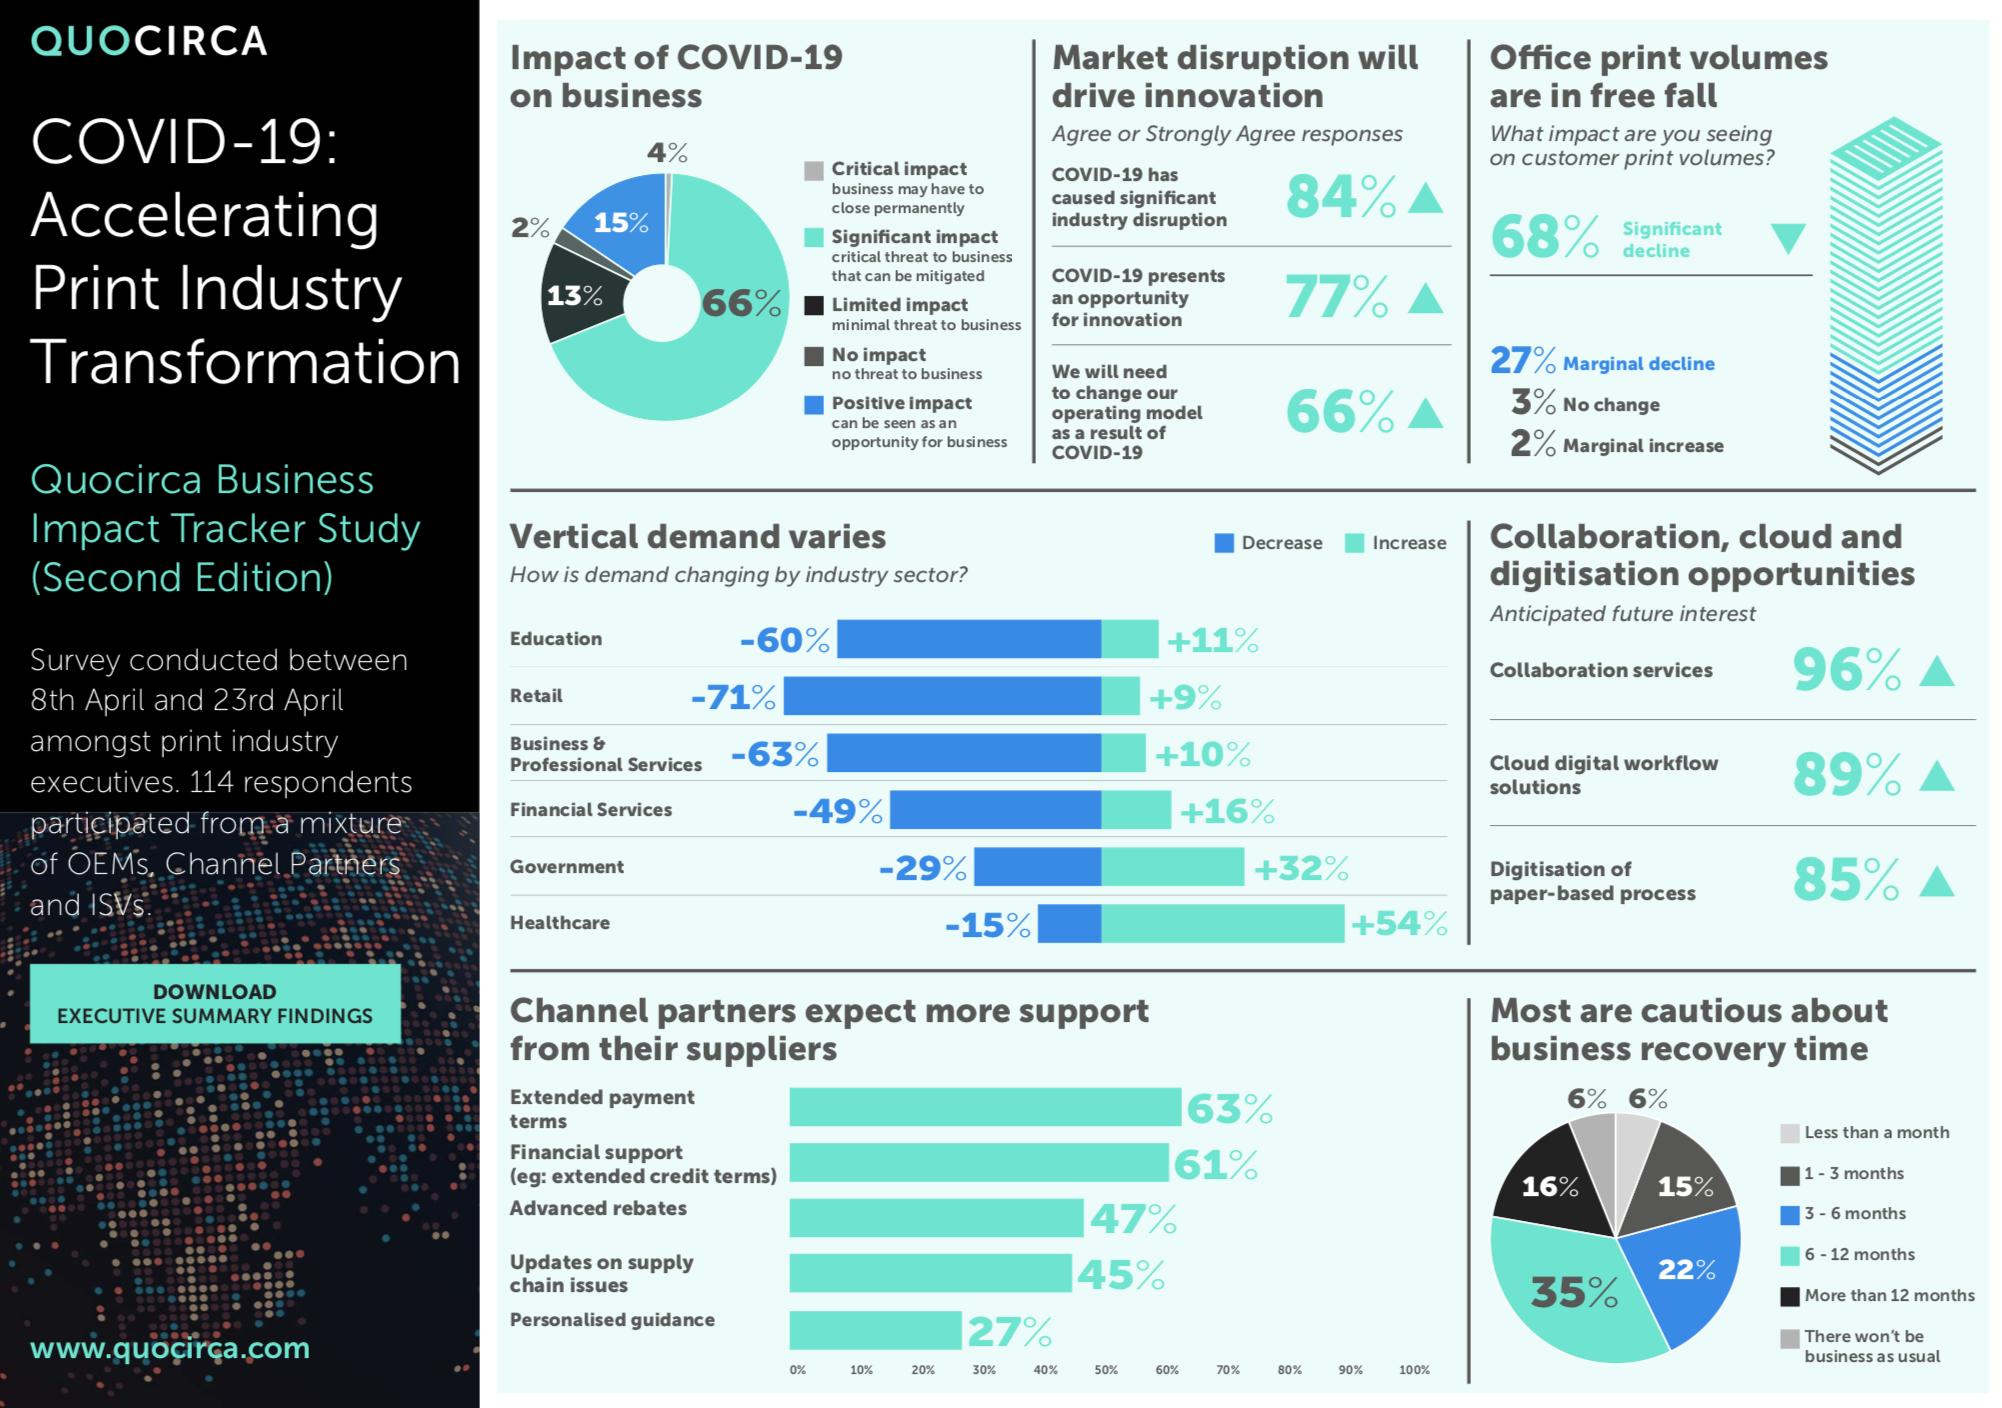List a handful of essential elements in this visual. According to the report, approximately 4% of businesses may have to permanently close due to the pandemic. Demand in the government sector increased by 32%. COVID-19 had a positive impact on 15% of businesses. According to the survey, 13% of businesses are not significantly affected by COVID-19 and are expected to continue operating as usual. The healthcare industry sector is expected to experience the greatest increase in demand in the future. 